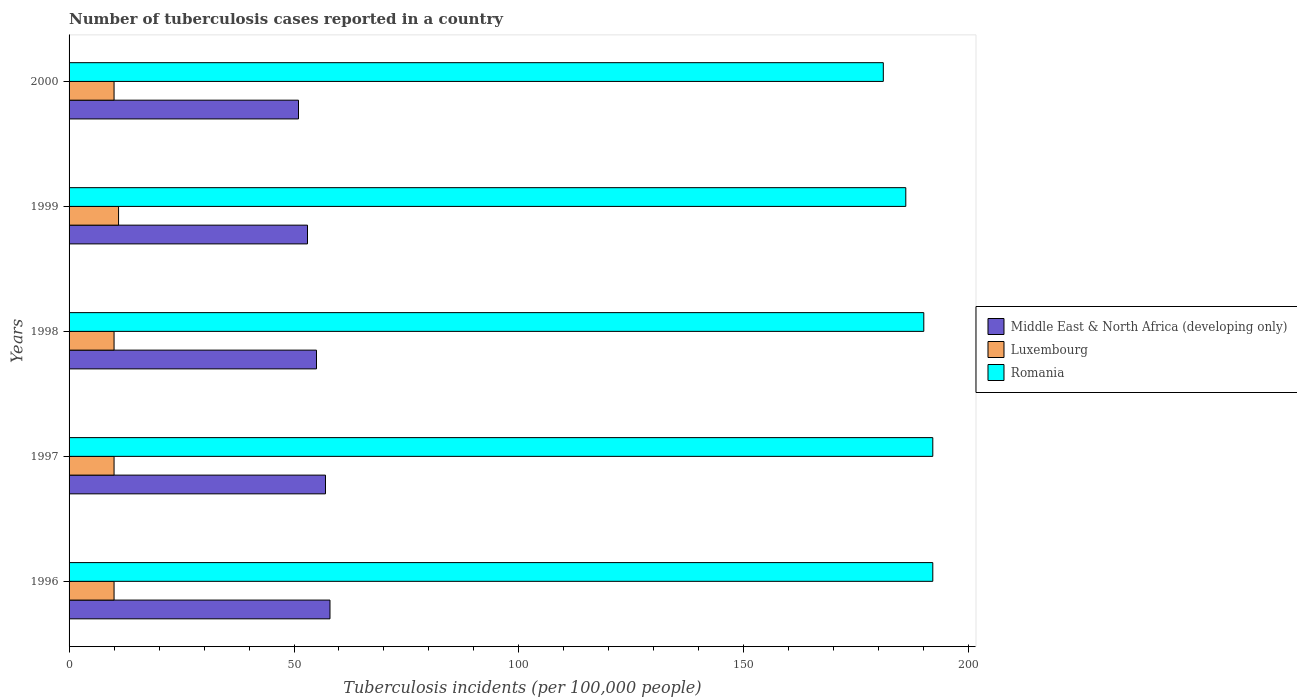How many groups of bars are there?
Your response must be concise. 5. Are the number of bars on each tick of the Y-axis equal?
Make the answer very short. Yes. How many bars are there on the 2nd tick from the top?
Your response must be concise. 3. How many bars are there on the 3rd tick from the bottom?
Provide a short and direct response. 3. In how many cases, is the number of bars for a given year not equal to the number of legend labels?
Give a very brief answer. 0. What is the number of tuberculosis cases reported in in Middle East & North Africa (developing only) in 1996?
Ensure brevity in your answer.  58. Across all years, what is the maximum number of tuberculosis cases reported in in Romania?
Give a very brief answer. 192. Across all years, what is the minimum number of tuberculosis cases reported in in Middle East & North Africa (developing only)?
Your answer should be very brief. 51. In which year was the number of tuberculosis cases reported in in Middle East & North Africa (developing only) minimum?
Provide a short and direct response. 2000. What is the total number of tuberculosis cases reported in in Middle East & North Africa (developing only) in the graph?
Your response must be concise. 274. What is the difference between the number of tuberculosis cases reported in in Middle East & North Africa (developing only) in 1998 and the number of tuberculosis cases reported in in Romania in 1999?
Ensure brevity in your answer.  -131. In the year 2000, what is the difference between the number of tuberculosis cases reported in in Middle East & North Africa (developing only) and number of tuberculosis cases reported in in Romania?
Ensure brevity in your answer.  -130. In how many years, is the number of tuberculosis cases reported in in Middle East & North Africa (developing only) greater than 80 ?
Offer a terse response. 0. What is the ratio of the number of tuberculosis cases reported in in Middle East & North Africa (developing only) in 1996 to that in 1999?
Give a very brief answer. 1.09. Is the difference between the number of tuberculosis cases reported in in Middle East & North Africa (developing only) in 1998 and 1999 greater than the difference between the number of tuberculosis cases reported in in Romania in 1998 and 1999?
Provide a succinct answer. No. What is the difference between the highest and the second highest number of tuberculosis cases reported in in Middle East & North Africa (developing only)?
Your answer should be compact. 1. What is the difference between the highest and the lowest number of tuberculosis cases reported in in Romania?
Ensure brevity in your answer.  11. In how many years, is the number of tuberculosis cases reported in in Romania greater than the average number of tuberculosis cases reported in in Romania taken over all years?
Ensure brevity in your answer.  3. What does the 3rd bar from the top in 1999 represents?
Ensure brevity in your answer.  Middle East & North Africa (developing only). What does the 1st bar from the bottom in 1998 represents?
Give a very brief answer. Middle East & North Africa (developing only). Is it the case that in every year, the sum of the number of tuberculosis cases reported in in Middle East & North Africa (developing only) and number of tuberculosis cases reported in in Luxembourg is greater than the number of tuberculosis cases reported in in Romania?
Provide a short and direct response. No. How many bars are there?
Your answer should be compact. 15. What is the difference between two consecutive major ticks on the X-axis?
Offer a very short reply. 50. Does the graph contain any zero values?
Your answer should be compact. No. Where does the legend appear in the graph?
Provide a succinct answer. Center right. How many legend labels are there?
Your answer should be compact. 3. What is the title of the graph?
Ensure brevity in your answer.  Number of tuberculosis cases reported in a country. Does "Canada" appear as one of the legend labels in the graph?
Ensure brevity in your answer.  No. What is the label or title of the X-axis?
Provide a short and direct response. Tuberculosis incidents (per 100,0 people). What is the label or title of the Y-axis?
Ensure brevity in your answer.  Years. What is the Tuberculosis incidents (per 100,000 people) of Luxembourg in 1996?
Provide a short and direct response. 10. What is the Tuberculosis incidents (per 100,000 people) of Romania in 1996?
Provide a succinct answer. 192. What is the Tuberculosis incidents (per 100,000 people) in Middle East & North Africa (developing only) in 1997?
Your answer should be compact. 57. What is the Tuberculosis incidents (per 100,000 people) in Romania in 1997?
Keep it short and to the point. 192. What is the Tuberculosis incidents (per 100,000 people) of Luxembourg in 1998?
Keep it short and to the point. 10. What is the Tuberculosis incidents (per 100,000 people) in Romania in 1998?
Provide a succinct answer. 190. What is the Tuberculosis incidents (per 100,000 people) in Middle East & North Africa (developing only) in 1999?
Your answer should be compact. 53. What is the Tuberculosis incidents (per 100,000 people) in Romania in 1999?
Your response must be concise. 186. What is the Tuberculosis incidents (per 100,000 people) of Romania in 2000?
Your answer should be very brief. 181. Across all years, what is the maximum Tuberculosis incidents (per 100,000 people) in Luxembourg?
Ensure brevity in your answer.  11. Across all years, what is the maximum Tuberculosis incidents (per 100,000 people) of Romania?
Offer a terse response. 192. Across all years, what is the minimum Tuberculosis incidents (per 100,000 people) of Luxembourg?
Your response must be concise. 10. Across all years, what is the minimum Tuberculosis incidents (per 100,000 people) in Romania?
Your response must be concise. 181. What is the total Tuberculosis incidents (per 100,000 people) of Middle East & North Africa (developing only) in the graph?
Give a very brief answer. 274. What is the total Tuberculosis incidents (per 100,000 people) of Luxembourg in the graph?
Your response must be concise. 51. What is the total Tuberculosis incidents (per 100,000 people) of Romania in the graph?
Give a very brief answer. 941. What is the difference between the Tuberculosis incidents (per 100,000 people) in Middle East & North Africa (developing only) in 1996 and that in 1998?
Make the answer very short. 3. What is the difference between the Tuberculosis incidents (per 100,000 people) in Luxembourg in 1996 and that in 1998?
Your response must be concise. 0. What is the difference between the Tuberculosis incidents (per 100,000 people) of Romania in 1996 and that in 1998?
Your answer should be very brief. 2. What is the difference between the Tuberculosis incidents (per 100,000 people) in Middle East & North Africa (developing only) in 1996 and that in 1999?
Make the answer very short. 5. What is the difference between the Tuberculosis incidents (per 100,000 people) in Romania in 1996 and that in 1999?
Offer a terse response. 6. What is the difference between the Tuberculosis incidents (per 100,000 people) in Middle East & North Africa (developing only) in 1996 and that in 2000?
Offer a terse response. 7. What is the difference between the Tuberculosis incidents (per 100,000 people) of Luxembourg in 1996 and that in 2000?
Offer a very short reply. 0. What is the difference between the Tuberculosis incidents (per 100,000 people) of Romania in 1996 and that in 2000?
Provide a succinct answer. 11. What is the difference between the Tuberculosis incidents (per 100,000 people) of Romania in 1997 and that in 1998?
Your answer should be very brief. 2. What is the difference between the Tuberculosis incidents (per 100,000 people) of Romania in 1997 and that in 1999?
Keep it short and to the point. 6. What is the difference between the Tuberculosis incidents (per 100,000 people) in Middle East & North Africa (developing only) in 1997 and that in 2000?
Your answer should be compact. 6. What is the difference between the Tuberculosis incidents (per 100,000 people) of Luxembourg in 1997 and that in 2000?
Make the answer very short. 0. What is the difference between the Tuberculosis incidents (per 100,000 people) of Romania in 1997 and that in 2000?
Give a very brief answer. 11. What is the difference between the Tuberculosis incidents (per 100,000 people) in Middle East & North Africa (developing only) in 1998 and that in 2000?
Your response must be concise. 4. What is the difference between the Tuberculosis incidents (per 100,000 people) in Middle East & North Africa (developing only) in 1999 and that in 2000?
Ensure brevity in your answer.  2. What is the difference between the Tuberculosis incidents (per 100,000 people) of Romania in 1999 and that in 2000?
Give a very brief answer. 5. What is the difference between the Tuberculosis incidents (per 100,000 people) in Middle East & North Africa (developing only) in 1996 and the Tuberculosis incidents (per 100,000 people) in Luxembourg in 1997?
Ensure brevity in your answer.  48. What is the difference between the Tuberculosis incidents (per 100,000 people) in Middle East & North Africa (developing only) in 1996 and the Tuberculosis incidents (per 100,000 people) in Romania in 1997?
Offer a terse response. -134. What is the difference between the Tuberculosis incidents (per 100,000 people) of Luxembourg in 1996 and the Tuberculosis incidents (per 100,000 people) of Romania in 1997?
Ensure brevity in your answer.  -182. What is the difference between the Tuberculosis incidents (per 100,000 people) of Middle East & North Africa (developing only) in 1996 and the Tuberculosis incidents (per 100,000 people) of Romania in 1998?
Your answer should be very brief. -132. What is the difference between the Tuberculosis incidents (per 100,000 people) in Luxembourg in 1996 and the Tuberculosis incidents (per 100,000 people) in Romania in 1998?
Give a very brief answer. -180. What is the difference between the Tuberculosis incidents (per 100,000 people) in Middle East & North Africa (developing only) in 1996 and the Tuberculosis incidents (per 100,000 people) in Luxembourg in 1999?
Give a very brief answer. 47. What is the difference between the Tuberculosis incidents (per 100,000 people) in Middle East & North Africa (developing only) in 1996 and the Tuberculosis incidents (per 100,000 people) in Romania in 1999?
Your answer should be compact. -128. What is the difference between the Tuberculosis incidents (per 100,000 people) in Luxembourg in 1996 and the Tuberculosis incidents (per 100,000 people) in Romania in 1999?
Ensure brevity in your answer.  -176. What is the difference between the Tuberculosis incidents (per 100,000 people) of Middle East & North Africa (developing only) in 1996 and the Tuberculosis incidents (per 100,000 people) of Romania in 2000?
Keep it short and to the point. -123. What is the difference between the Tuberculosis incidents (per 100,000 people) in Luxembourg in 1996 and the Tuberculosis incidents (per 100,000 people) in Romania in 2000?
Your response must be concise. -171. What is the difference between the Tuberculosis incidents (per 100,000 people) of Middle East & North Africa (developing only) in 1997 and the Tuberculosis incidents (per 100,000 people) of Luxembourg in 1998?
Your response must be concise. 47. What is the difference between the Tuberculosis incidents (per 100,000 people) in Middle East & North Africa (developing only) in 1997 and the Tuberculosis incidents (per 100,000 people) in Romania in 1998?
Offer a terse response. -133. What is the difference between the Tuberculosis incidents (per 100,000 people) of Luxembourg in 1997 and the Tuberculosis incidents (per 100,000 people) of Romania in 1998?
Your answer should be very brief. -180. What is the difference between the Tuberculosis incidents (per 100,000 people) of Middle East & North Africa (developing only) in 1997 and the Tuberculosis incidents (per 100,000 people) of Romania in 1999?
Offer a terse response. -129. What is the difference between the Tuberculosis incidents (per 100,000 people) of Luxembourg in 1997 and the Tuberculosis incidents (per 100,000 people) of Romania in 1999?
Your response must be concise. -176. What is the difference between the Tuberculosis incidents (per 100,000 people) in Middle East & North Africa (developing only) in 1997 and the Tuberculosis incidents (per 100,000 people) in Luxembourg in 2000?
Ensure brevity in your answer.  47. What is the difference between the Tuberculosis incidents (per 100,000 people) in Middle East & North Africa (developing only) in 1997 and the Tuberculosis incidents (per 100,000 people) in Romania in 2000?
Your answer should be compact. -124. What is the difference between the Tuberculosis incidents (per 100,000 people) in Luxembourg in 1997 and the Tuberculosis incidents (per 100,000 people) in Romania in 2000?
Provide a short and direct response. -171. What is the difference between the Tuberculosis incidents (per 100,000 people) in Middle East & North Africa (developing only) in 1998 and the Tuberculosis incidents (per 100,000 people) in Luxembourg in 1999?
Your answer should be compact. 44. What is the difference between the Tuberculosis incidents (per 100,000 people) of Middle East & North Africa (developing only) in 1998 and the Tuberculosis incidents (per 100,000 people) of Romania in 1999?
Your answer should be very brief. -131. What is the difference between the Tuberculosis incidents (per 100,000 people) in Luxembourg in 1998 and the Tuberculosis incidents (per 100,000 people) in Romania in 1999?
Provide a succinct answer. -176. What is the difference between the Tuberculosis incidents (per 100,000 people) of Middle East & North Africa (developing only) in 1998 and the Tuberculosis incidents (per 100,000 people) of Luxembourg in 2000?
Keep it short and to the point. 45. What is the difference between the Tuberculosis incidents (per 100,000 people) in Middle East & North Africa (developing only) in 1998 and the Tuberculosis incidents (per 100,000 people) in Romania in 2000?
Offer a terse response. -126. What is the difference between the Tuberculosis incidents (per 100,000 people) of Luxembourg in 1998 and the Tuberculosis incidents (per 100,000 people) of Romania in 2000?
Keep it short and to the point. -171. What is the difference between the Tuberculosis incidents (per 100,000 people) of Middle East & North Africa (developing only) in 1999 and the Tuberculosis incidents (per 100,000 people) of Luxembourg in 2000?
Provide a succinct answer. 43. What is the difference between the Tuberculosis incidents (per 100,000 people) in Middle East & North Africa (developing only) in 1999 and the Tuberculosis incidents (per 100,000 people) in Romania in 2000?
Make the answer very short. -128. What is the difference between the Tuberculosis incidents (per 100,000 people) of Luxembourg in 1999 and the Tuberculosis incidents (per 100,000 people) of Romania in 2000?
Your answer should be very brief. -170. What is the average Tuberculosis incidents (per 100,000 people) of Middle East & North Africa (developing only) per year?
Offer a terse response. 54.8. What is the average Tuberculosis incidents (per 100,000 people) of Romania per year?
Your answer should be compact. 188.2. In the year 1996, what is the difference between the Tuberculosis incidents (per 100,000 people) in Middle East & North Africa (developing only) and Tuberculosis incidents (per 100,000 people) in Romania?
Give a very brief answer. -134. In the year 1996, what is the difference between the Tuberculosis incidents (per 100,000 people) in Luxembourg and Tuberculosis incidents (per 100,000 people) in Romania?
Your response must be concise. -182. In the year 1997, what is the difference between the Tuberculosis incidents (per 100,000 people) of Middle East & North Africa (developing only) and Tuberculosis incidents (per 100,000 people) of Luxembourg?
Give a very brief answer. 47. In the year 1997, what is the difference between the Tuberculosis incidents (per 100,000 people) of Middle East & North Africa (developing only) and Tuberculosis incidents (per 100,000 people) of Romania?
Your response must be concise. -135. In the year 1997, what is the difference between the Tuberculosis incidents (per 100,000 people) in Luxembourg and Tuberculosis incidents (per 100,000 people) in Romania?
Your answer should be very brief. -182. In the year 1998, what is the difference between the Tuberculosis incidents (per 100,000 people) of Middle East & North Africa (developing only) and Tuberculosis incidents (per 100,000 people) of Romania?
Make the answer very short. -135. In the year 1998, what is the difference between the Tuberculosis incidents (per 100,000 people) of Luxembourg and Tuberculosis incidents (per 100,000 people) of Romania?
Give a very brief answer. -180. In the year 1999, what is the difference between the Tuberculosis incidents (per 100,000 people) in Middle East & North Africa (developing only) and Tuberculosis incidents (per 100,000 people) in Luxembourg?
Ensure brevity in your answer.  42. In the year 1999, what is the difference between the Tuberculosis incidents (per 100,000 people) in Middle East & North Africa (developing only) and Tuberculosis incidents (per 100,000 people) in Romania?
Give a very brief answer. -133. In the year 1999, what is the difference between the Tuberculosis incidents (per 100,000 people) in Luxembourg and Tuberculosis incidents (per 100,000 people) in Romania?
Ensure brevity in your answer.  -175. In the year 2000, what is the difference between the Tuberculosis incidents (per 100,000 people) of Middle East & North Africa (developing only) and Tuberculosis incidents (per 100,000 people) of Luxembourg?
Give a very brief answer. 41. In the year 2000, what is the difference between the Tuberculosis incidents (per 100,000 people) of Middle East & North Africa (developing only) and Tuberculosis incidents (per 100,000 people) of Romania?
Make the answer very short. -130. In the year 2000, what is the difference between the Tuberculosis incidents (per 100,000 people) in Luxembourg and Tuberculosis incidents (per 100,000 people) in Romania?
Provide a succinct answer. -171. What is the ratio of the Tuberculosis incidents (per 100,000 people) of Middle East & North Africa (developing only) in 1996 to that in 1997?
Your response must be concise. 1.02. What is the ratio of the Tuberculosis incidents (per 100,000 people) of Luxembourg in 1996 to that in 1997?
Keep it short and to the point. 1. What is the ratio of the Tuberculosis incidents (per 100,000 people) in Romania in 1996 to that in 1997?
Make the answer very short. 1. What is the ratio of the Tuberculosis incidents (per 100,000 people) of Middle East & North Africa (developing only) in 1996 to that in 1998?
Your answer should be compact. 1.05. What is the ratio of the Tuberculosis incidents (per 100,000 people) of Luxembourg in 1996 to that in 1998?
Ensure brevity in your answer.  1. What is the ratio of the Tuberculosis incidents (per 100,000 people) in Romania in 1996 to that in 1998?
Offer a terse response. 1.01. What is the ratio of the Tuberculosis incidents (per 100,000 people) in Middle East & North Africa (developing only) in 1996 to that in 1999?
Provide a short and direct response. 1.09. What is the ratio of the Tuberculosis incidents (per 100,000 people) in Luxembourg in 1996 to that in 1999?
Your answer should be compact. 0.91. What is the ratio of the Tuberculosis incidents (per 100,000 people) of Romania in 1996 to that in 1999?
Give a very brief answer. 1.03. What is the ratio of the Tuberculosis incidents (per 100,000 people) in Middle East & North Africa (developing only) in 1996 to that in 2000?
Offer a terse response. 1.14. What is the ratio of the Tuberculosis incidents (per 100,000 people) in Romania in 1996 to that in 2000?
Offer a very short reply. 1.06. What is the ratio of the Tuberculosis incidents (per 100,000 people) of Middle East & North Africa (developing only) in 1997 to that in 1998?
Your answer should be compact. 1.04. What is the ratio of the Tuberculosis incidents (per 100,000 people) in Romania in 1997 to that in 1998?
Keep it short and to the point. 1.01. What is the ratio of the Tuberculosis incidents (per 100,000 people) of Middle East & North Africa (developing only) in 1997 to that in 1999?
Your answer should be compact. 1.08. What is the ratio of the Tuberculosis incidents (per 100,000 people) of Romania in 1997 to that in 1999?
Provide a succinct answer. 1.03. What is the ratio of the Tuberculosis incidents (per 100,000 people) in Middle East & North Africa (developing only) in 1997 to that in 2000?
Offer a very short reply. 1.12. What is the ratio of the Tuberculosis incidents (per 100,000 people) in Luxembourg in 1997 to that in 2000?
Offer a terse response. 1. What is the ratio of the Tuberculosis incidents (per 100,000 people) in Romania in 1997 to that in 2000?
Offer a very short reply. 1.06. What is the ratio of the Tuberculosis incidents (per 100,000 people) of Middle East & North Africa (developing only) in 1998 to that in 1999?
Your answer should be compact. 1.04. What is the ratio of the Tuberculosis incidents (per 100,000 people) of Romania in 1998 to that in 1999?
Ensure brevity in your answer.  1.02. What is the ratio of the Tuberculosis incidents (per 100,000 people) of Middle East & North Africa (developing only) in 1998 to that in 2000?
Make the answer very short. 1.08. What is the ratio of the Tuberculosis incidents (per 100,000 people) in Romania in 1998 to that in 2000?
Offer a very short reply. 1.05. What is the ratio of the Tuberculosis incidents (per 100,000 people) of Middle East & North Africa (developing only) in 1999 to that in 2000?
Offer a terse response. 1.04. What is the ratio of the Tuberculosis incidents (per 100,000 people) in Luxembourg in 1999 to that in 2000?
Ensure brevity in your answer.  1.1. What is the ratio of the Tuberculosis incidents (per 100,000 people) in Romania in 1999 to that in 2000?
Offer a very short reply. 1.03. What is the difference between the highest and the second highest Tuberculosis incidents (per 100,000 people) of Middle East & North Africa (developing only)?
Provide a succinct answer. 1. What is the difference between the highest and the second highest Tuberculosis incidents (per 100,000 people) of Luxembourg?
Your answer should be compact. 1. What is the difference between the highest and the second highest Tuberculosis incidents (per 100,000 people) in Romania?
Your answer should be compact. 0. What is the difference between the highest and the lowest Tuberculosis incidents (per 100,000 people) in Middle East & North Africa (developing only)?
Offer a terse response. 7. What is the difference between the highest and the lowest Tuberculosis incidents (per 100,000 people) of Luxembourg?
Offer a very short reply. 1. 